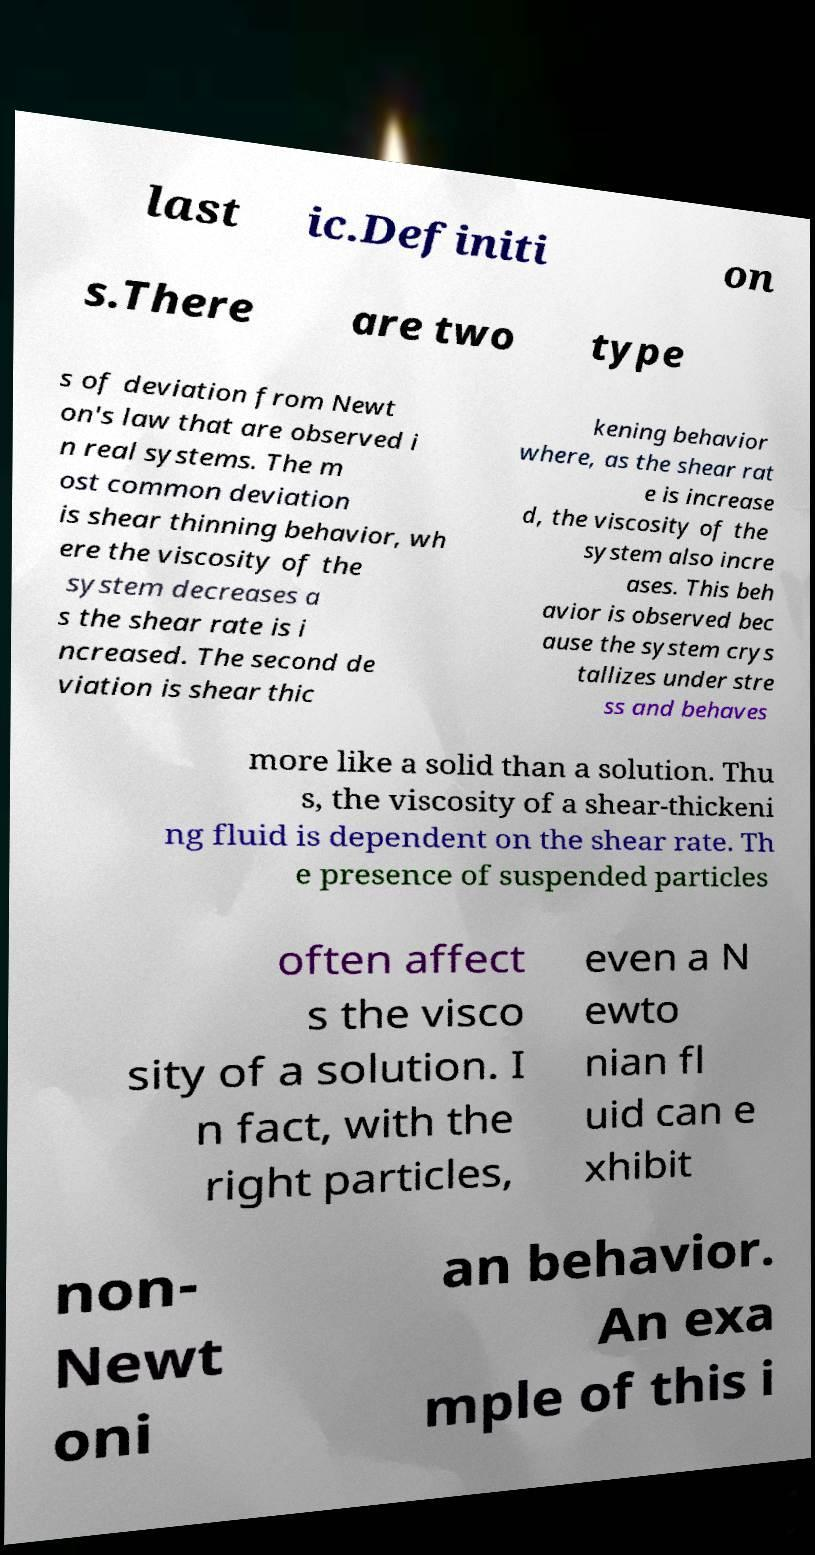There's text embedded in this image that I need extracted. Can you transcribe it verbatim? last ic.Definiti on s.There are two type s of deviation from Newt on's law that are observed i n real systems. The m ost common deviation is shear thinning behavior, wh ere the viscosity of the system decreases a s the shear rate is i ncreased. The second de viation is shear thic kening behavior where, as the shear rat e is increase d, the viscosity of the system also incre ases. This beh avior is observed bec ause the system crys tallizes under stre ss and behaves more like a solid than a solution. Thu s, the viscosity of a shear-thickeni ng fluid is dependent on the shear rate. Th e presence of suspended particles often affect s the visco sity of a solution. I n fact, with the right particles, even a N ewto nian fl uid can e xhibit non- Newt oni an behavior. An exa mple of this i 